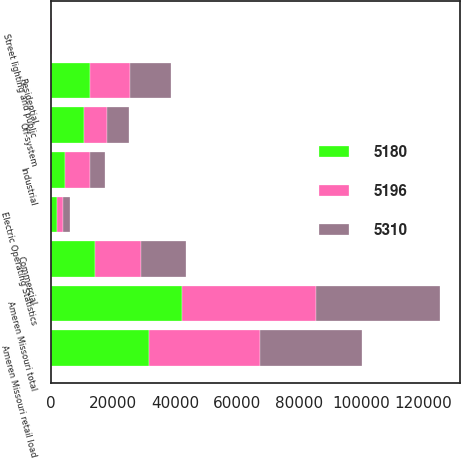<chart> <loc_0><loc_0><loc_500><loc_500><stacked_bar_chart><ecel><fcel>Electric Operating Statistics<fcel>Residential<fcel>Commercial<fcel>Industrial<fcel>Street lighting and public<fcel>Ameren Missouri retail load<fcel>Off-system<fcel>Ameren Missouri total<nl><fcel>5180<fcel>2017<fcel>12653<fcel>14384<fcel>4469<fcel>117<fcel>31623<fcel>10640<fcel>42263<nl><fcel>5310<fcel>2016<fcel>13245<fcel>14712<fcel>4790<fcel>125<fcel>32872<fcel>7125<fcel>39997<nl><fcel>5196<fcel>2015<fcel>12903<fcel>14574<fcel>8273<fcel>126<fcel>35876<fcel>7380<fcel>43256<nl></chart> 